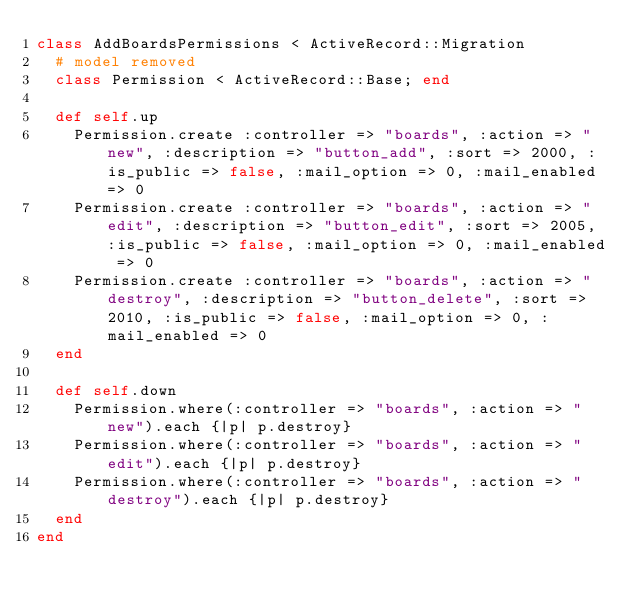<code> <loc_0><loc_0><loc_500><loc_500><_Ruby_>class AddBoardsPermissions < ActiveRecord::Migration
  # model removed
  class Permission < ActiveRecord::Base; end

  def self.up
    Permission.create :controller => "boards", :action => "new", :description => "button_add", :sort => 2000, :is_public => false, :mail_option => 0, :mail_enabled => 0
    Permission.create :controller => "boards", :action => "edit", :description => "button_edit", :sort => 2005, :is_public => false, :mail_option => 0, :mail_enabled => 0
    Permission.create :controller => "boards", :action => "destroy", :description => "button_delete", :sort => 2010, :is_public => false, :mail_option => 0, :mail_enabled => 0
  end

  def self.down
    Permission.where(:controller => "boards", :action => "new").each {|p| p.destroy}
    Permission.where(:controller => "boards", :action => "edit").each {|p| p.destroy}
    Permission.where(:controller => "boards", :action => "destroy").each {|p| p.destroy}
  end
end
</code> 